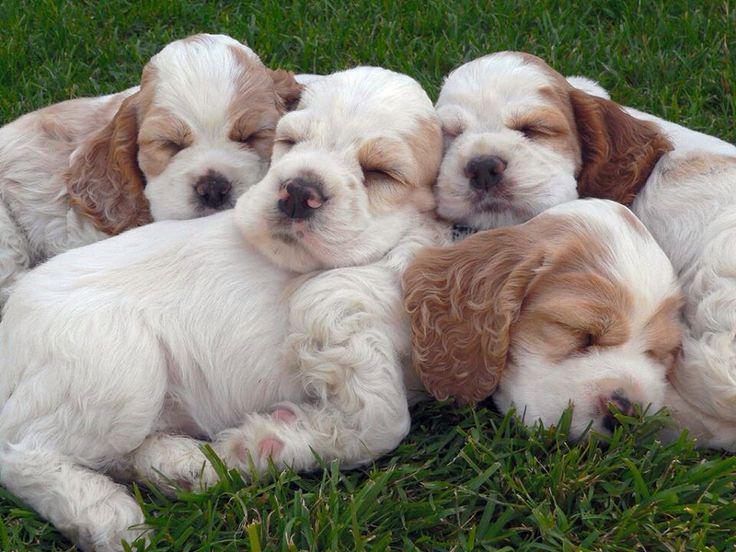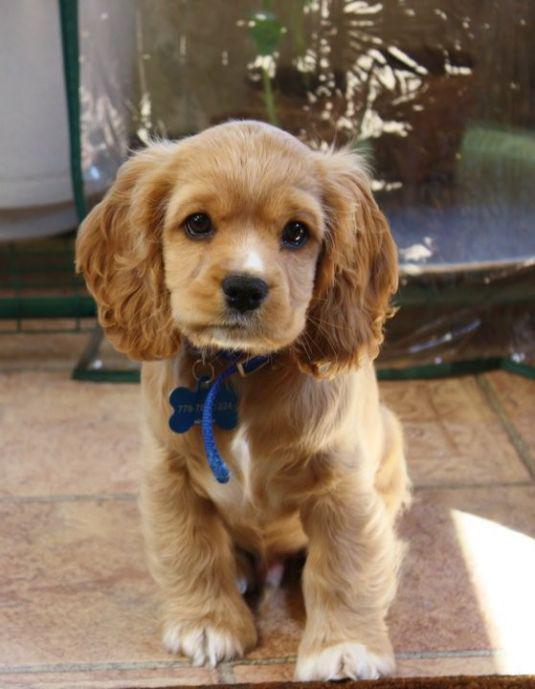The first image is the image on the left, the second image is the image on the right. Given the left and right images, does the statement "The left image contains at least three dogs." hold true? Answer yes or no. Yes. The first image is the image on the left, the second image is the image on the right. Analyze the images presented: Is the assertion "The left image shows no less than three spaniel puppies, and the right image shows just one spaniel sitting" valid? Answer yes or no. Yes. 